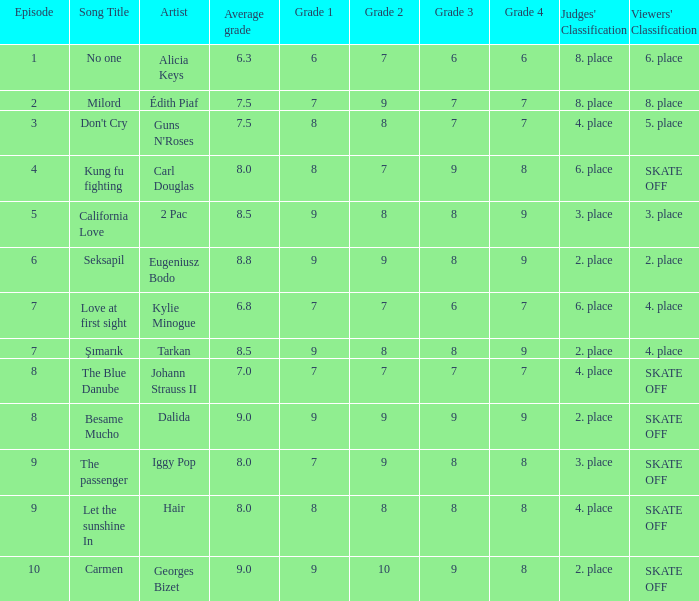Name the classification for 9, 9, 8, 9 2. place. 